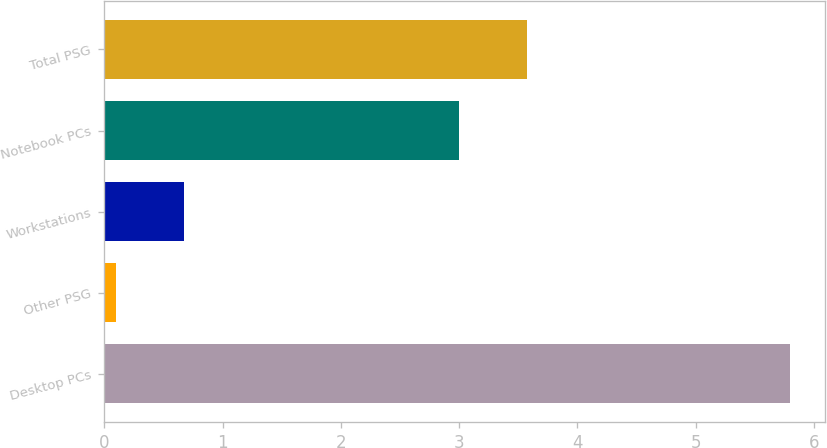Convert chart. <chart><loc_0><loc_0><loc_500><loc_500><bar_chart><fcel>Desktop PCs<fcel>Other PSG<fcel>Workstations<fcel>Notebook PCs<fcel>Total PSG<nl><fcel>5.8<fcel>0.1<fcel>0.67<fcel>3<fcel>3.57<nl></chart> 